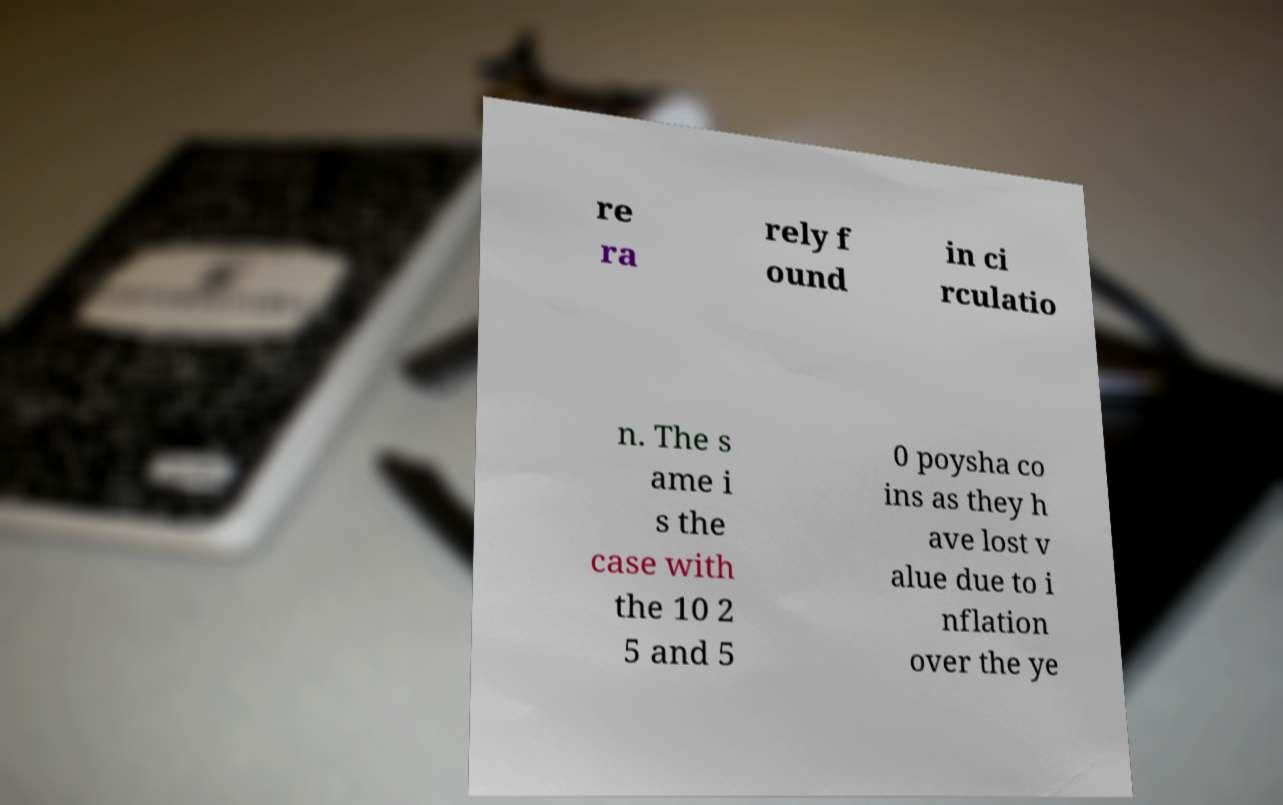For documentation purposes, I need the text within this image transcribed. Could you provide that? re ra rely f ound in ci rculatio n. The s ame i s the case with the 10 2 5 and 5 0 poysha co ins as they h ave lost v alue due to i nflation over the ye 